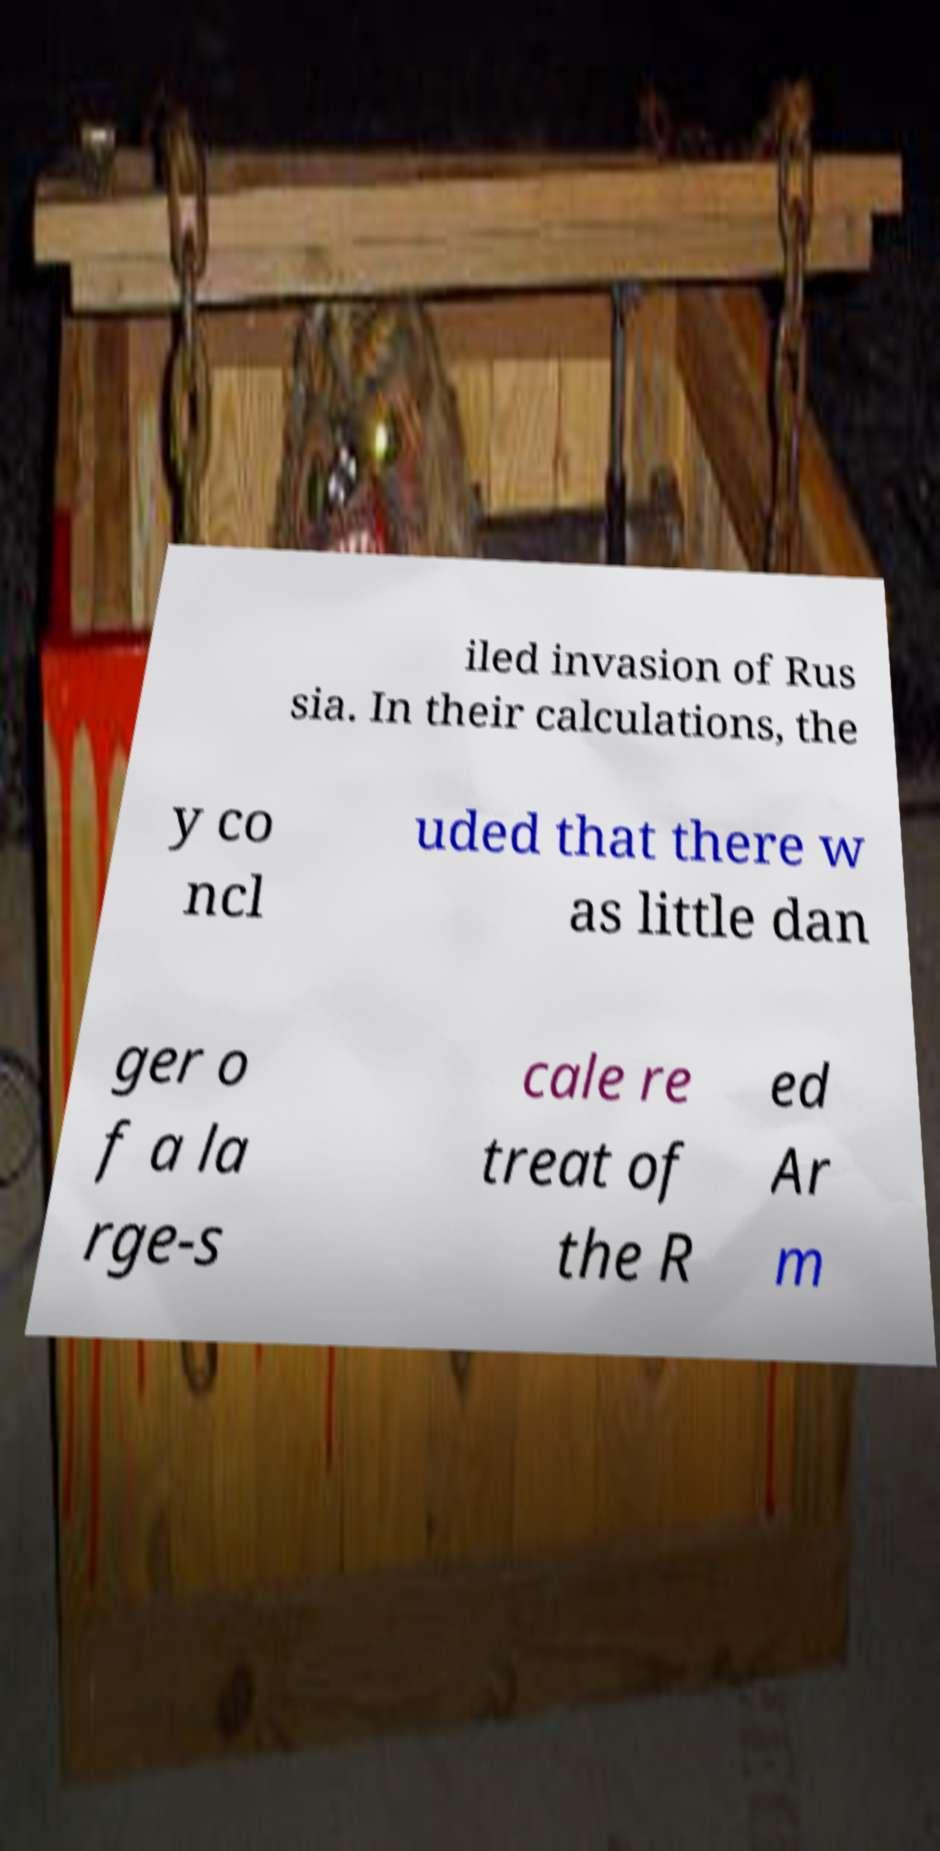There's text embedded in this image that I need extracted. Can you transcribe it verbatim? iled invasion of Rus sia. In their calculations, the y co ncl uded that there w as little dan ger o f a la rge-s cale re treat of the R ed Ar m 